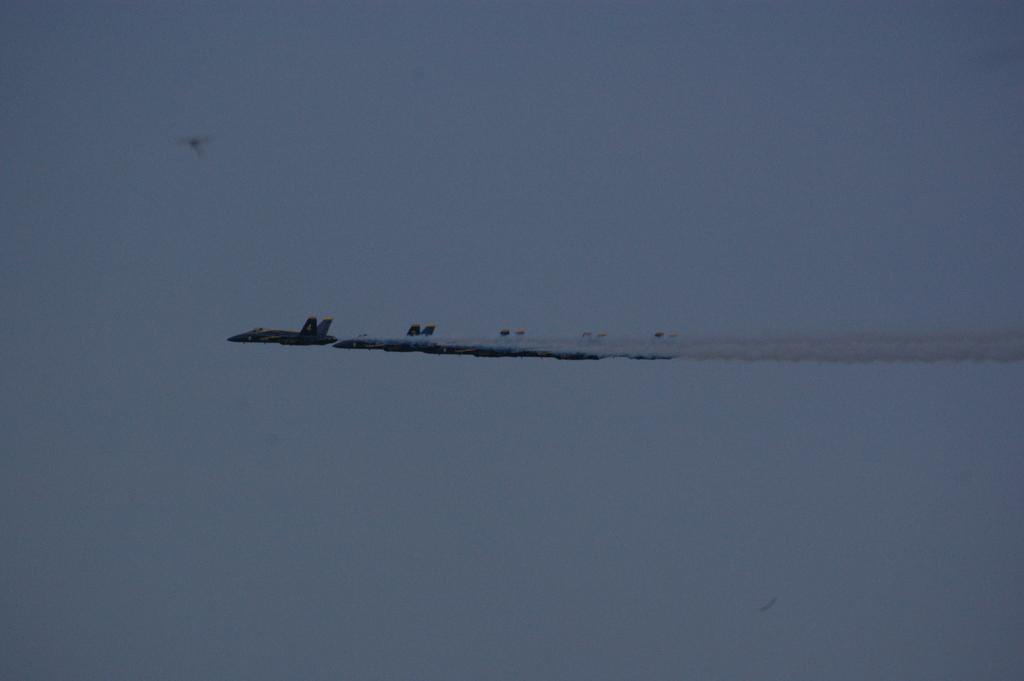What is the main subject of the image? The main subject of the image is aircrafts flying. What can be seen in the background of the image? The sky is visible in the background of the image. Can you hear the birds crying in the image? There are no birds or any indication of crying sounds in the image. 